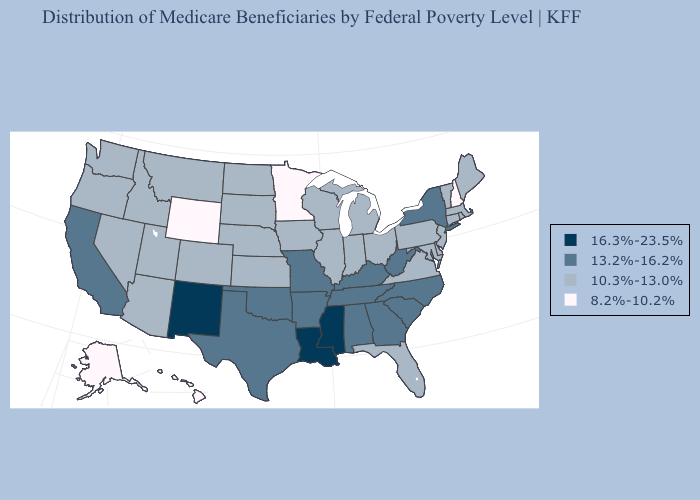What is the value of Maryland?
Short answer required. 10.3%-13.0%. What is the highest value in the USA?
Be succinct. 16.3%-23.5%. Does Mississippi have the highest value in the South?
Write a very short answer. Yes. Does Louisiana have a lower value than Florida?
Write a very short answer. No. Name the states that have a value in the range 13.2%-16.2%?
Write a very short answer. Alabama, Arkansas, California, Georgia, Kentucky, Missouri, New York, North Carolina, Oklahoma, South Carolina, Tennessee, Texas, West Virginia. Does Nebraska have the lowest value in the MidWest?
Answer briefly. No. Does the first symbol in the legend represent the smallest category?
Keep it brief. No. What is the value of Hawaii?
Be succinct. 8.2%-10.2%. Does Arkansas have the highest value in the USA?
Give a very brief answer. No. What is the value of West Virginia?
Write a very short answer. 13.2%-16.2%. What is the value of Virginia?
Write a very short answer. 10.3%-13.0%. How many symbols are there in the legend?
Quick response, please. 4. What is the value of Pennsylvania?
Keep it brief. 10.3%-13.0%. What is the value of Illinois?
Answer briefly. 10.3%-13.0%. Which states have the lowest value in the South?
Short answer required. Delaware, Florida, Maryland, Virginia. 